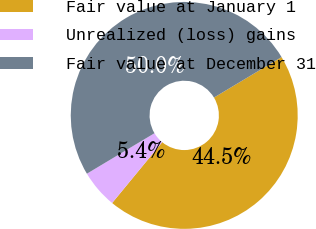<chart> <loc_0><loc_0><loc_500><loc_500><pie_chart><fcel>Fair value at January 1<fcel>Unrealized (loss) gains<fcel>Fair value at December 31<nl><fcel>44.55%<fcel>5.45%<fcel>50.0%<nl></chart> 